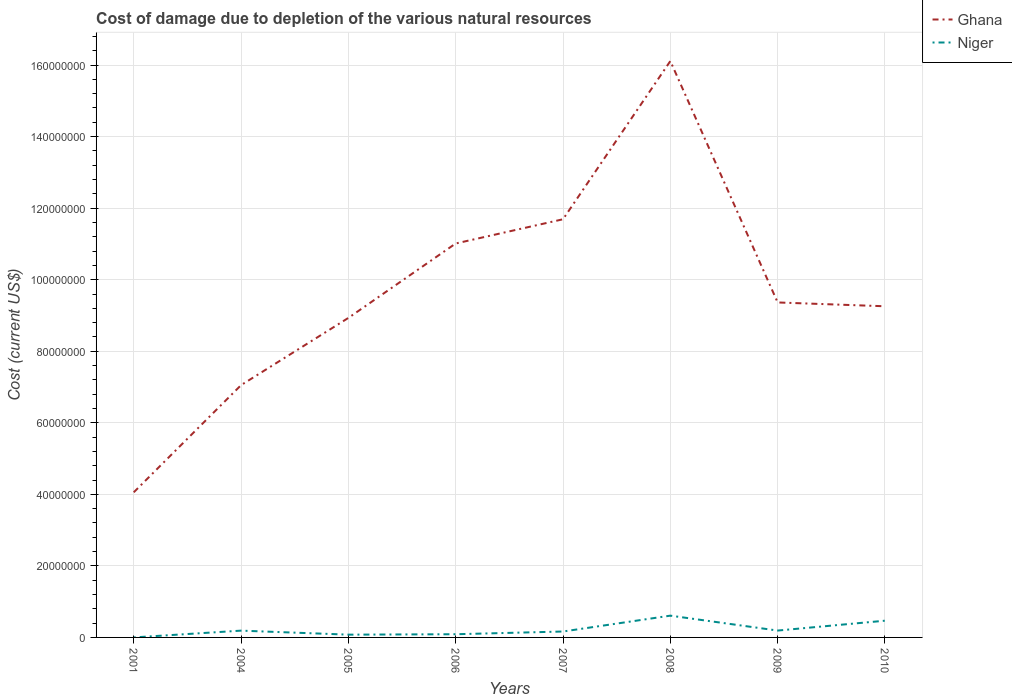How many different coloured lines are there?
Make the answer very short. 2. Across all years, what is the maximum cost of damage caused due to the depletion of various natural resources in Niger?
Offer a very short reply. 1901.53. What is the total cost of damage caused due to the depletion of various natural resources in Ghana in the graph?
Provide a short and direct response. 1.07e+06. What is the difference between the highest and the second highest cost of damage caused due to the depletion of various natural resources in Ghana?
Keep it short and to the point. 1.21e+08. Are the values on the major ticks of Y-axis written in scientific E-notation?
Make the answer very short. No. Does the graph contain any zero values?
Your answer should be compact. No. Does the graph contain grids?
Offer a terse response. Yes. What is the title of the graph?
Your answer should be very brief. Cost of damage due to depletion of the various natural resources. Does "Europe(developing only)" appear as one of the legend labels in the graph?
Offer a very short reply. No. What is the label or title of the Y-axis?
Offer a terse response. Cost (current US$). What is the Cost (current US$) in Ghana in 2001?
Offer a terse response. 4.06e+07. What is the Cost (current US$) of Niger in 2001?
Your response must be concise. 1901.53. What is the Cost (current US$) of Ghana in 2004?
Provide a succinct answer. 7.05e+07. What is the Cost (current US$) of Niger in 2004?
Make the answer very short. 1.90e+06. What is the Cost (current US$) in Ghana in 2005?
Your response must be concise. 8.93e+07. What is the Cost (current US$) of Niger in 2005?
Offer a terse response. 7.75e+05. What is the Cost (current US$) in Ghana in 2006?
Give a very brief answer. 1.10e+08. What is the Cost (current US$) in Niger in 2006?
Give a very brief answer. 8.93e+05. What is the Cost (current US$) in Ghana in 2007?
Make the answer very short. 1.17e+08. What is the Cost (current US$) of Niger in 2007?
Provide a succinct answer. 1.65e+06. What is the Cost (current US$) in Ghana in 2008?
Provide a succinct answer. 1.61e+08. What is the Cost (current US$) in Niger in 2008?
Ensure brevity in your answer.  6.09e+06. What is the Cost (current US$) in Ghana in 2009?
Keep it short and to the point. 9.36e+07. What is the Cost (current US$) in Niger in 2009?
Your answer should be very brief. 1.92e+06. What is the Cost (current US$) of Ghana in 2010?
Provide a short and direct response. 9.26e+07. What is the Cost (current US$) in Niger in 2010?
Provide a short and direct response. 4.68e+06. Across all years, what is the maximum Cost (current US$) of Ghana?
Your response must be concise. 1.61e+08. Across all years, what is the maximum Cost (current US$) in Niger?
Provide a short and direct response. 6.09e+06. Across all years, what is the minimum Cost (current US$) of Ghana?
Your response must be concise. 4.06e+07. Across all years, what is the minimum Cost (current US$) of Niger?
Keep it short and to the point. 1901.53. What is the total Cost (current US$) of Ghana in the graph?
Your response must be concise. 7.75e+08. What is the total Cost (current US$) of Niger in the graph?
Provide a short and direct response. 1.79e+07. What is the difference between the Cost (current US$) of Ghana in 2001 and that in 2004?
Your response must be concise. -3.00e+07. What is the difference between the Cost (current US$) in Niger in 2001 and that in 2004?
Your answer should be very brief. -1.90e+06. What is the difference between the Cost (current US$) of Ghana in 2001 and that in 2005?
Offer a very short reply. -4.88e+07. What is the difference between the Cost (current US$) in Niger in 2001 and that in 2005?
Your answer should be very brief. -7.73e+05. What is the difference between the Cost (current US$) in Ghana in 2001 and that in 2006?
Provide a short and direct response. -6.96e+07. What is the difference between the Cost (current US$) in Niger in 2001 and that in 2006?
Make the answer very short. -8.91e+05. What is the difference between the Cost (current US$) in Ghana in 2001 and that in 2007?
Offer a terse response. -7.63e+07. What is the difference between the Cost (current US$) of Niger in 2001 and that in 2007?
Ensure brevity in your answer.  -1.65e+06. What is the difference between the Cost (current US$) in Ghana in 2001 and that in 2008?
Ensure brevity in your answer.  -1.21e+08. What is the difference between the Cost (current US$) in Niger in 2001 and that in 2008?
Your response must be concise. -6.09e+06. What is the difference between the Cost (current US$) of Ghana in 2001 and that in 2009?
Offer a terse response. -5.31e+07. What is the difference between the Cost (current US$) in Niger in 2001 and that in 2009?
Give a very brief answer. -1.92e+06. What is the difference between the Cost (current US$) of Ghana in 2001 and that in 2010?
Ensure brevity in your answer.  -5.20e+07. What is the difference between the Cost (current US$) in Niger in 2001 and that in 2010?
Provide a succinct answer. -4.68e+06. What is the difference between the Cost (current US$) of Ghana in 2004 and that in 2005?
Your answer should be compact. -1.88e+07. What is the difference between the Cost (current US$) in Niger in 2004 and that in 2005?
Your answer should be very brief. 1.12e+06. What is the difference between the Cost (current US$) in Ghana in 2004 and that in 2006?
Your answer should be very brief. -3.96e+07. What is the difference between the Cost (current US$) in Niger in 2004 and that in 2006?
Provide a short and direct response. 1.00e+06. What is the difference between the Cost (current US$) of Ghana in 2004 and that in 2007?
Keep it short and to the point. -4.64e+07. What is the difference between the Cost (current US$) of Niger in 2004 and that in 2007?
Keep it short and to the point. 2.44e+05. What is the difference between the Cost (current US$) of Ghana in 2004 and that in 2008?
Provide a succinct answer. -9.06e+07. What is the difference between the Cost (current US$) of Niger in 2004 and that in 2008?
Provide a succinct answer. -4.19e+06. What is the difference between the Cost (current US$) in Ghana in 2004 and that in 2009?
Give a very brief answer. -2.31e+07. What is the difference between the Cost (current US$) of Niger in 2004 and that in 2009?
Your response must be concise. -2.09e+04. What is the difference between the Cost (current US$) in Ghana in 2004 and that in 2010?
Your answer should be very brief. -2.20e+07. What is the difference between the Cost (current US$) of Niger in 2004 and that in 2010?
Provide a short and direct response. -2.78e+06. What is the difference between the Cost (current US$) of Ghana in 2005 and that in 2006?
Give a very brief answer. -2.08e+07. What is the difference between the Cost (current US$) in Niger in 2005 and that in 2006?
Make the answer very short. -1.19e+05. What is the difference between the Cost (current US$) in Ghana in 2005 and that in 2007?
Give a very brief answer. -2.76e+07. What is the difference between the Cost (current US$) of Niger in 2005 and that in 2007?
Your answer should be very brief. -8.79e+05. What is the difference between the Cost (current US$) in Ghana in 2005 and that in 2008?
Your answer should be very brief. -7.18e+07. What is the difference between the Cost (current US$) of Niger in 2005 and that in 2008?
Give a very brief answer. -5.31e+06. What is the difference between the Cost (current US$) in Ghana in 2005 and that in 2009?
Provide a succinct answer. -4.32e+06. What is the difference between the Cost (current US$) in Niger in 2005 and that in 2009?
Make the answer very short. -1.14e+06. What is the difference between the Cost (current US$) of Ghana in 2005 and that in 2010?
Provide a succinct answer. -3.26e+06. What is the difference between the Cost (current US$) of Niger in 2005 and that in 2010?
Keep it short and to the point. -3.90e+06. What is the difference between the Cost (current US$) of Ghana in 2006 and that in 2007?
Make the answer very short. -6.77e+06. What is the difference between the Cost (current US$) in Niger in 2006 and that in 2007?
Your response must be concise. -7.61e+05. What is the difference between the Cost (current US$) in Ghana in 2006 and that in 2008?
Your answer should be very brief. -5.10e+07. What is the difference between the Cost (current US$) of Niger in 2006 and that in 2008?
Provide a short and direct response. -5.19e+06. What is the difference between the Cost (current US$) of Ghana in 2006 and that in 2009?
Your answer should be compact. 1.65e+07. What is the difference between the Cost (current US$) in Niger in 2006 and that in 2009?
Keep it short and to the point. -1.03e+06. What is the difference between the Cost (current US$) in Ghana in 2006 and that in 2010?
Keep it short and to the point. 1.76e+07. What is the difference between the Cost (current US$) in Niger in 2006 and that in 2010?
Provide a succinct answer. -3.78e+06. What is the difference between the Cost (current US$) in Ghana in 2007 and that in 2008?
Give a very brief answer. -4.42e+07. What is the difference between the Cost (current US$) in Niger in 2007 and that in 2008?
Keep it short and to the point. -4.43e+06. What is the difference between the Cost (current US$) in Ghana in 2007 and that in 2009?
Provide a short and direct response. 2.33e+07. What is the difference between the Cost (current US$) of Niger in 2007 and that in 2009?
Provide a short and direct response. -2.65e+05. What is the difference between the Cost (current US$) of Ghana in 2007 and that in 2010?
Provide a succinct answer. 2.43e+07. What is the difference between the Cost (current US$) of Niger in 2007 and that in 2010?
Provide a short and direct response. -3.02e+06. What is the difference between the Cost (current US$) in Ghana in 2008 and that in 2009?
Your response must be concise. 6.75e+07. What is the difference between the Cost (current US$) in Niger in 2008 and that in 2009?
Give a very brief answer. 4.17e+06. What is the difference between the Cost (current US$) of Ghana in 2008 and that in 2010?
Your answer should be very brief. 6.85e+07. What is the difference between the Cost (current US$) in Niger in 2008 and that in 2010?
Give a very brief answer. 1.41e+06. What is the difference between the Cost (current US$) of Ghana in 2009 and that in 2010?
Provide a short and direct response. 1.07e+06. What is the difference between the Cost (current US$) of Niger in 2009 and that in 2010?
Your answer should be very brief. -2.76e+06. What is the difference between the Cost (current US$) of Ghana in 2001 and the Cost (current US$) of Niger in 2004?
Your answer should be very brief. 3.87e+07. What is the difference between the Cost (current US$) of Ghana in 2001 and the Cost (current US$) of Niger in 2005?
Your answer should be very brief. 3.98e+07. What is the difference between the Cost (current US$) in Ghana in 2001 and the Cost (current US$) in Niger in 2006?
Make the answer very short. 3.97e+07. What is the difference between the Cost (current US$) of Ghana in 2001 and the Cost (current US$) of Niger in 2007?
Offer a terse response. 3.89e+07. What is the difference between the Cost (current US$) in Ghana in 2001 and the Cost (current US$) in Niger in 2008?
Your answer should be very brief. 3.45e+07. What is the difference between the Cost (current US$) in Ghana in 2001 and the Cost (current US$) in Niger in 2009?
Make the answer very short. 3.86e+07. What is the difference between the Cost (current US$) of Ghana in 2001 and the Cost (current US$) of Niger in 2010?
Offer a very short reply. 3.59e+07. What is the difference between the Cost (current US$) in Ghana in 2004 and the Cost (current US$) in Niger in 2005?
Provide a succinct answer. 6.98e+07. What is the difference between the Cost (current US$) in Ghana in 2004 and the Cost (current US$) in Niger in 2006?
Make the answer very short. 6.96e+07. What is the difference between the Cost (current US$) of Ghana in 2004 and the Cost (current US$) of Niger in 2007?
Keep it short and to the point. 6.89e+07. What is the difference between the Cost (current US$) in Ghana in 2004 and the Cost (current US$) in Niger in 2008?
Your answer should be compact. 6.44e+07. What is the difference between the Cost (current US$) in Ghana in 2004 and the Cost (current US$) in Niger in 2009?
Ensure brevity in your answer.  6.86e+07. What is the difference between the Cost (current US$) of Ghana in 2004 and the Cost (current US$) of Niger in 2010?
Make the answer very short. 6.58e+07. What is the difference between the Cost (current US$) of Ghana in 2005 and the Cost (current US$) of Niger in 2006?
Your answer should be compact. 8.84e+07. What is the difference between the Cost (current US$) in Ghana in 2005 and the Cost (current US$) in Niger in 2007?
Offer a terse response. 8.77e+07. What is the difference between the Cost (current US$) in Ghana in 2005 and the Cost (current US$) in Niger in 2008?
Provide a succinct answer. 8.32e+07. What is the difference between the Cost (current US$) of Ghana in 2005 and the Cost (current US$) of Niger in 2009?
Provide a short and direct response. 8.74e+07. What is the difference between the Cost (current US$) of Ghana in 2005 and the Cost (current US$) of Niger in 2010?
Offer a very short reply. 8.46e+07. What is the difference between the Cost (current US$) of Ghana in 2006 and the Cost (current US$) of Niger in 2007?
Keep it short and to the point. 1.08e+08. What is the difference between the Cost (current US$) in Ghana in 2006 and the Cost (current US$) in Niger in 2008?
Give a very brief answer. 1.04e+08. What is the difference between the Cost (current US$) of Ghana in 2006 and the Cost (current US$) of Niger in 2009?
Your answer should be compact. 1.08e+08. What is the difference between the Cost (current US$) in Ghana in 2006 and the Cost (current US$) in Niger in 2010?
Provide a succinct answer. 1.05e+08. What is the difference between the Cost (current US$) in Ghana in 2007 and the Cost (current US$) in Niger in 2008?
Offer a terse response. 1.11e+08. What is the difference between the Cost (current US$) of Ghana in 2007 and the Cost (current US$) of Niger in 2009?
Provide a succinct answer. 1.15e+08. What is the difference between the Cost (current US$) in Ghana in 2007 and the Cost (current US$) in Niger in 2010?
Your answer should be very brief. 1.12e+08. What is the difference between the Cost (current US$) in Ghana in 2008 and the Cost (current US$) in Niger in 2009?
Your answer should be very brief. 1.59e+08. What is the difference between the Cost (current US$) in Ghana in 2008 and the Cost (current US$) in Niger in 2010?
Provide a succinct answer. 1.56e+08. What is the difference between the Cost (current US$) of Ghana in 2009 and the Cost (current US$) of Niger in 2010?
Provide a succinct answer. 8.90e+07. What is the average Cost (current US$) of Ghana per year?
Ensure brevity in your answer.  9.68e+07. What is the average Cost (current US$) of Niger per year?
Your answer should be compact. 2.24e+06. In the year 2001, what is the difference between the Cost (current US$) of Ghana and Cost (current US$) of Niger?
Make the answer very short. 4.06e+07. In the year 2004, what is the difference between the Cost (current US$) in Ghana and Cost (current US$) in Niger?
Make the answer very short. 6.86e+07. In the year 2005, what is the difference between the Cost (current US$) of Ghana and Cost (current US$) of Niger?
Provide a succinct answer. 8.85e+07. In the year 2006, what is the difference between the Cost (current US$) in Ghana and Cost (current US$) in Niger?
Give a very brief answer. 1.09e+08. In the year 2007, what is the difference between the Cost (current US$) of Ghana and Cost (current US$) of Niger?
Your answer should be very brief. 1.15e+08. In the year 2008, what is the difference between the Cost (current US$) of Ghana and Cost (current US$) of Niger?
Make the answer very short. 1.55e+08. In the year 2009, what is the difference between the Cost (current US$) in Ghana and Cost (current US$) in Niger?
Your answer should be very brief. 9.17e+07. In the year 2010, what is the difference between the Cost (current US$) in Ghana and Cost (current US$) in Niger?
Your answer should be compact. 8.79e+07. What is the ratio of the Cost (current US$) of Ghana in 2001 to that in 2004?
Keep it short and to the point. 0.58. What is the ratio of the Cost (current US$) in Niger in 2001 to that in 2004?
Your answer should be very brief. 0. What is the ratio of the Cost (current US$) of Ghana in 2001 to that in 2005?
Give a very brief answer. 0.45. What is the ratio of the Cost (current US$) in Niger in 2001 to that in 2005?
Give a very brief answer. 0. What is the ratio of the Cost (current US$) in Ghana in 2001 to that in 2006?
Your answer should be very brief. 0.37. What is the ratio of the Cost (current US$) of Niger in 2001 to that in 2006?
Your answer should be very brief. 0. What is the ratio of the Cost (current US$) of Ghana in 2001 to that in 2007?
Provide a short and direct response. 0.35. What is the ratio of the Cost (current US$) of Niger in 2001 to that in 2007?
Provide a succinct answer. 0. What is the ratio of the Cost (current US$) of Ghana in 2001 to that in 2008?
Make the answer very short. 0.25. What is the ratio of the Cost (current US$) in Ghana in 2001 to that in 2009?
Give a very brief answer. 0.43. What is the ratio of the Cost (current US$) in Ghana in 2001 to that in 2010?
Ensure brevity in your answer.  0.44. What is the ratio of the Cost (current US$) in Ghana in 2004 to that in 2005?
Keep it short and to the point. 0.79. What is the ratio of the Cost (current US$) of Niger in 2004 to that in 2005?
Provide a succinct answer. 2.45. What is the ratio of the Cost (current US$) of Ghana in 2004 to that in 2006?
Ensure brevity in your answer.  0.64. What is the ratio of the Cost (current US$) in Niger in 2004 to that in 2006?
Provide a succinct answer. 2.12. What is the ratio of the Cost (current US$) of Ghana in 2004 to that in 2007?
Offer a terse response. 0.6. What is the ratio of the Cost (current US$) of Niger in 2004 to that in 2007?
Provide a short and direct response. 1.15. What is the ratio of the Cost (current US$) in Ghana in 2004 to that in 2008?
Offer a terse response. 0.44. What is the ratio of the Cost (current US$) of Niger in 2004 to that in 2008?
Offer a very short reply. 0.31. What is the ratio of the Cost (current US$) of Ghana in 2004 to that in 2009?
Your answer should be compact. 0.75. What is the ratio of the Cost (current US$) of Ghana in 2004 to that in 2010?
Offer a terse response. 0.76. What is the ratio of the Cost (current US$) of Niger in 2004 to that in 2010?
Offer a terse response. 0.41. What is the ratio of the Cost (current US$) in Ghana in 2005 to that in 2006?
Keep it short and to the point. 0.81. What is the ratio of the Cost (current US$) of Niger in 2005 to that in 2006?
Offer a very short reply. 0.87. What is the ratio of the Cost (current US$) in Ghana in 2005 to that in 2007?
Provide a succinct answer. 0.76. What is the ratio of the Cost (current US$) of Niger in 2005 to that in 2007?
Your response must be concise. 0.47. What is the ratio of the Cost (current US$) of Ghana in 2005 to that in 2008?
Provide a short and direct response. 0.55. What is the ratio of the Cost (current US$) of Niger in 2005 to that in 2008?
Give a very brief answer. 0.13. What is the ratio of the Cost (current US$) of Ghana in 2005 to that in 2009?
Your response must be concise. 0.95. What is the ratio of the Cost (current US$) in Niger in 2005 to that in 2009?
Provide a succinct answer. 0.4. What is the ratio of the Cost (current US$) of Ghana in 2005 to that in 2010?
Give a very brief answer. 0.96. What is the ratio of the Cost (current US$) in Niger in 2005 to that in 2010?
Ensure brevity in your answer.  0.17. What is the ratio of the Cost (current US$) of Ghana in 2006 to that in 2007?
Ensure brevity in your answer.  0.94. What is the ratio of the Cost (current US$) in Niger in 2006 to that in 2007?
Your answer should be compact. 0.54. What is the ratio of the Cost (current US$) in Ghana in 2006 to that in 2008?
Keep it short and to the point. 0.68. What is the ratio of the Cost (current US$) in Niger in 2006 to that in 2008?
Your answer should be compact. 0.15. What is the ratio of the Cost (current US$) in Ghana in 2006 to that in 2009?
Give a very brief answer. 1.18. What is the ratio of the Cost (current US$) of Niger in 2006 to that in 2009?
Make the answer very short. 0.47. What is the ratio of the Cost (current US$) in Ghana in 2006 to that in 2010?
Keep it short and to the point. 1.19. What is the ratio of the Cost (current US$) of Niger in 2006 to that in 2010?
Offer a terse response. 0.19. What is the ratio of the Cost (current US$) of Ghana in 2007 to that in 2008?
Your answer should be compact. 0.73. What is the ratio of the Cost (current US$) of Niger in 2007 to that in 2008?
Make the answer very short. 0.27. What is the ratio of the Cost (current US$) of Ghana in 2007 to that in 2009?
Provide a short and direct response. 1.25. What is the ratio of the Cost (current US$) of Niger in 2007 to that in 2009?
Keep it short and to the point. 0.86. What is the ratio of the Cost (current US$) in Ghana in 2007 to that in 2010?
Keep it short and to the point. 1.26. What is the ratio of the Cost (current US$) of Niger in 2007 to that in 2010?
Offer a terse response. 0.35. What is the ratio of the Cost (current US$) of Ghana in 2008 to that in 2009?
Make the answer very short. 1.72. What is the ratio of the Cost (current US$) in Niger in 2008 to that in 2009?
Your answer should be compact. 3.17. What is the ratio of the Cost (current US$) in Ghana in 2008 to that in 2010?
Make the answer very short. 1.74. What is the ratio of the Cost (current US$) of Niger in 2008 to that in 2010?
Your response must be concise. 1.3. What is the ratio of the Cost (current US$) of Ghana in 2009 to that in 2010?
Your answer should be very brief. 1.01. What is the ratio of the Cost (current US$) in Niger in 2009 to that in 2010?
Offer a terse response. 0.41. What is the difference between the highest and the second highest Cost (current US$) of Ghana?
Give a very brief answer. 4.42e+07. What is the difference between the highest and the second highest Cost (current US$) of Niger?
Ensure brevity in your answer.  1.41e+06. What is the difference between the highest and the lowest Cost (current US$) of Ghana?
Make the answer very short. 1.21e+08. What is the difference between the highest and the lowest Cost (current US$) in Niger?
Offer a terse response. 6.09e+06. 